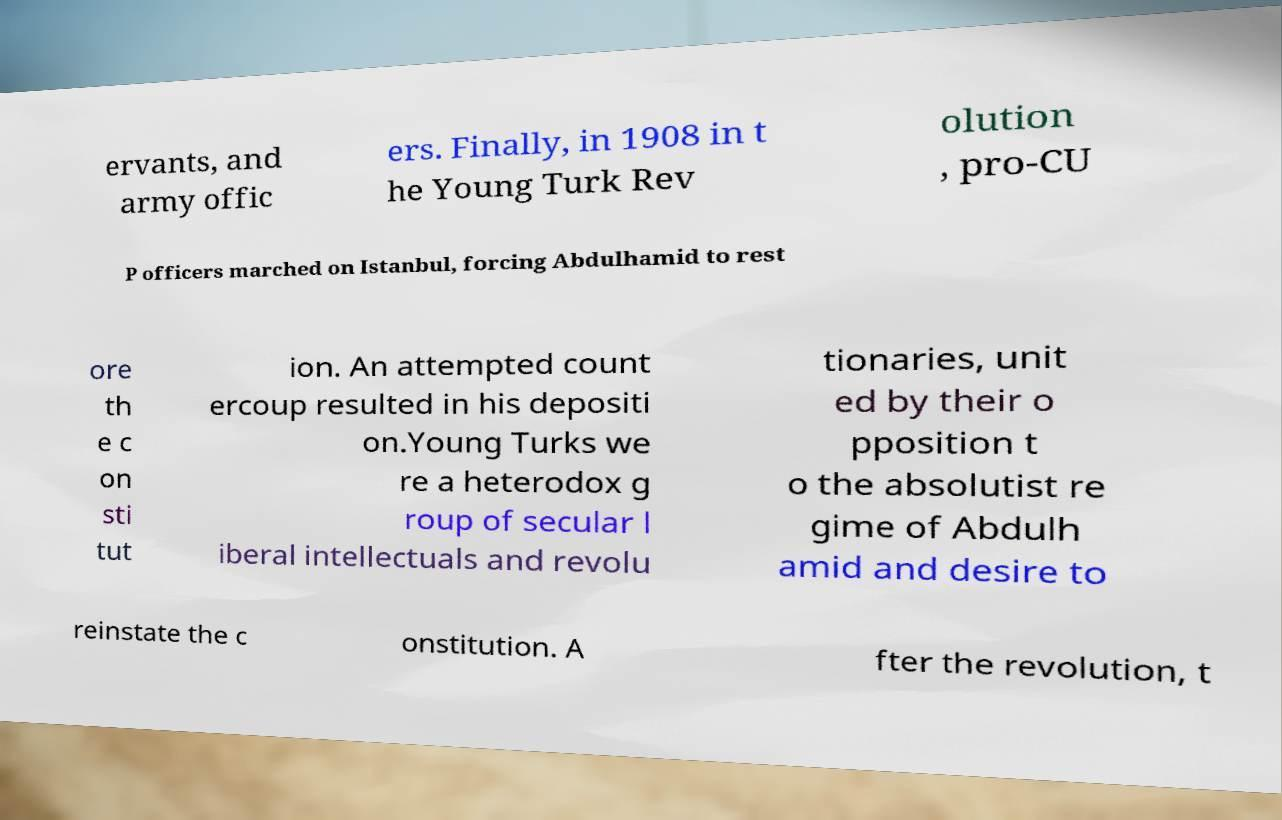Could you extract and type out the text from this image? ervants, and army offic ers. Finally, in 1908 in t he Young Turk Rev olution , pro-CU P officers marched on Istanbul, forcing Abdulhamid to rest ore th e c on sti tut ion. An attempted count ercoup resulted in his depositi on.Young Turks we re a heterodox g roup of secular l iberal intellectuals and revolu tionaries, unit ed by their o pposition t o the absolutist re gime of Abdulh amid and desire to reinstate the c onstitution. A fter the revolution, t 